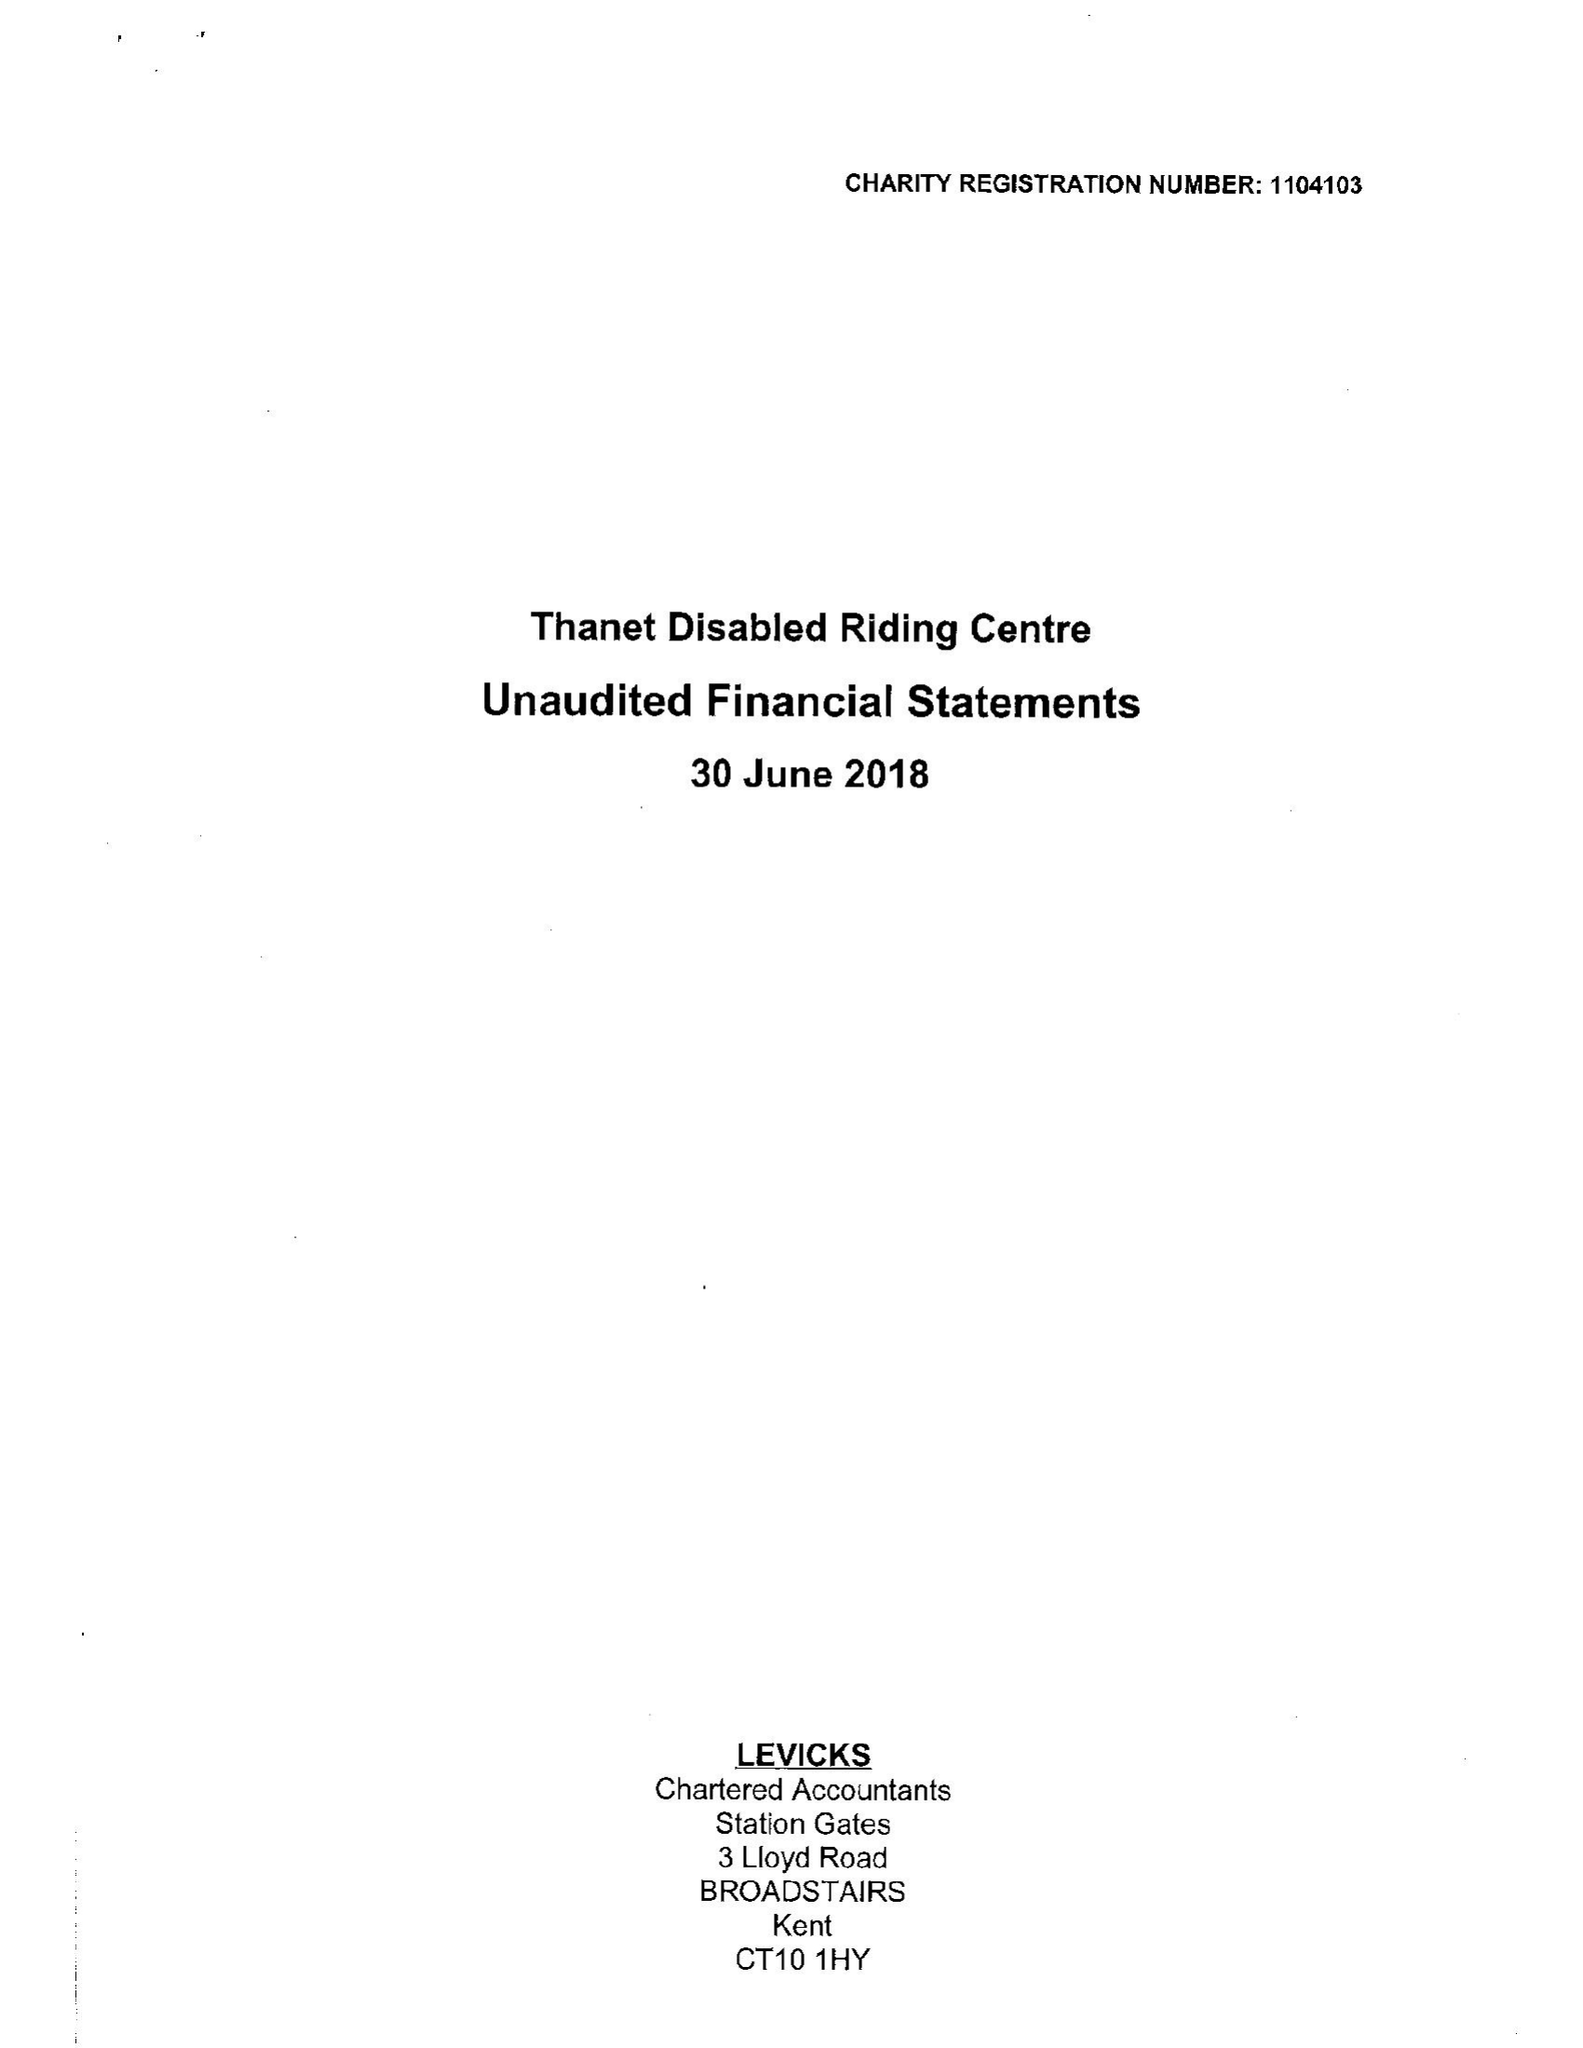What is the value for the address__street_line?
Answer the question using a single word or phrase. CALLIS COURT ROAD 